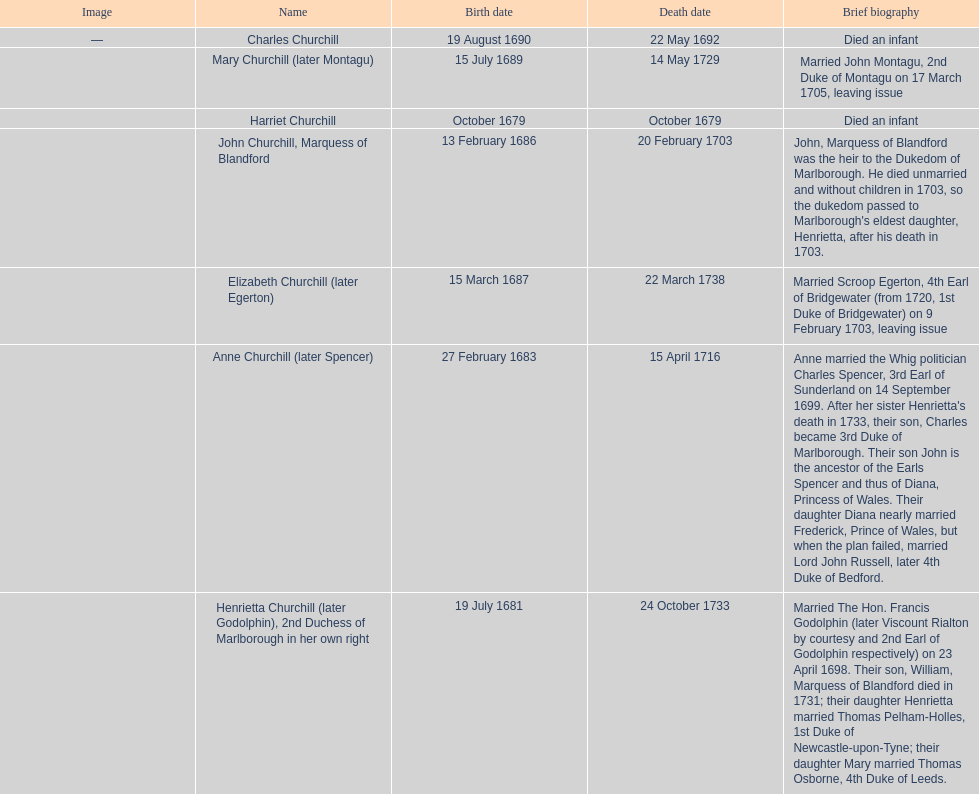Which child was born after elizabeth churchill? Mary Churchill. 